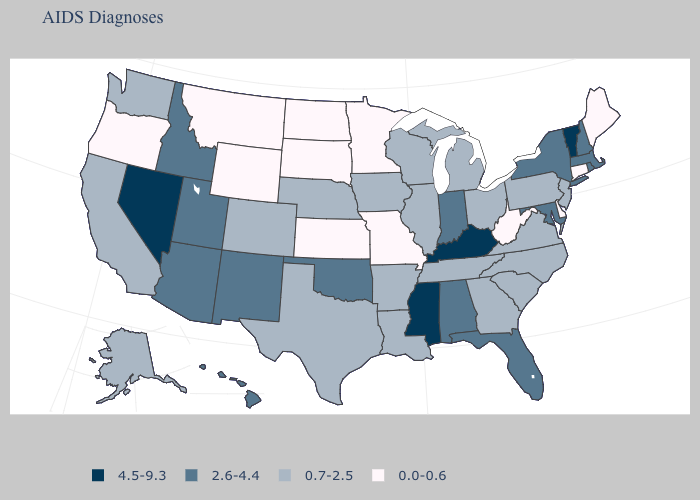Name the states that have a value in the range 0.7-2.5?
Be succinct. Alaska, Arkansas, California, Colorado, Georgia, Illinois, Iowa, Louisiana, Michigan, Nebraska, New Jersey, North Carolina, Ohio, Pennsylvania, South Carolina, Tennessee, Texas, Virginia, Washington, Wisconsin. What is the highest value in the USA?
Quick response, please. 4.5-9.3. Name the states that have a value in the range 0.0-0.6?
Be succinct. Connecticut, Delaware, Kansas, Maine, Minnesota, Missouri, Montana, North Dakota, Oregon, South Dakota, West Virginia, Wyoming. Name the states that have a value in the range 2.6-4.4?
Be succinct. Alabama, Arizona, Florida, Hawaii, Idaho, Indiana, Maryland, Massachusetts, New Hampshire, New Mexico, New York, Oklahoma, Rhode Island, Utah. Is the legend a continuous bar?
Write a very short answer. No. Does the map have missing data?
Answer briefly. No. Does Nevada have the highest value in the West?
Concise answer only. Yes. What is the value of Illinois?
Concise answer only. 0.7-2.5. How many symbols are there in the legend?
Quick response, please. 4. Does Iowa have the same value as Delaware?
Answer briefly. No. Name the states that have a value in the range 4.5-9.3?
Be succinct. Kentucky, Mississippi, Nevada, Vermont. Does Virginia have the lowest value in the USA?
Write a very short answer. No. Which states have the lowest value in the West?
Keep it brief. Montana, Oregon, Wyoming. What is the highest value in states that border Oklahoma?
Concise answer only. 2.6-4.4. Name the states that have a value in the range 2.6-4.4?
Concise answer only. Alabama, Arizona, Florida, Hawaii, Idaho, Indiana, Maryland, Massachusetts, New Hampshire, New Mexico, New York, Oklahoma, Rhode Island, Utah. 